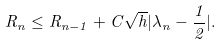<formula> <loc_0><loc_0><loc_500><loc_500>R _ { n } \leq R _ { n - 1 } + C \sqrt { h } | \lambda _ { n } - \frac { 1 } { 2 } | .</formula> 